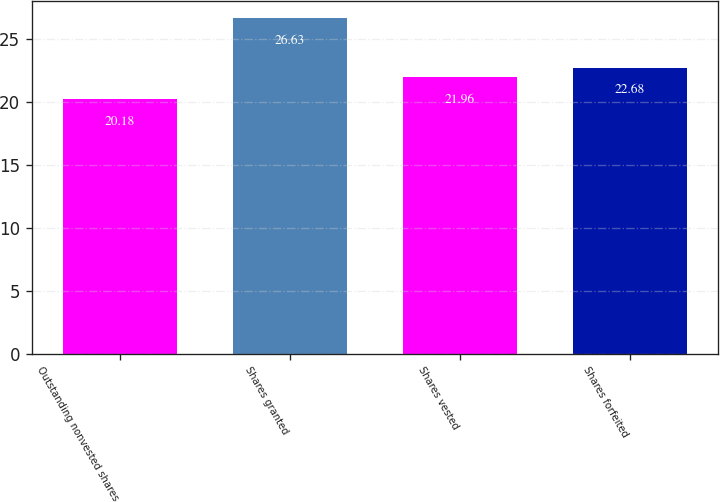Convert chart. <chart><loc_0><loc_0><loc_500><loc_500><bar_chart><fcel>Outstanding nonvested shares<fcel>Shares granted<fcel>Shares vested<fcel>Shares forfeited<nl><fcel>20.18<fcel>26.63<fcel>21.96<fcel>22.68<nl></chart> 